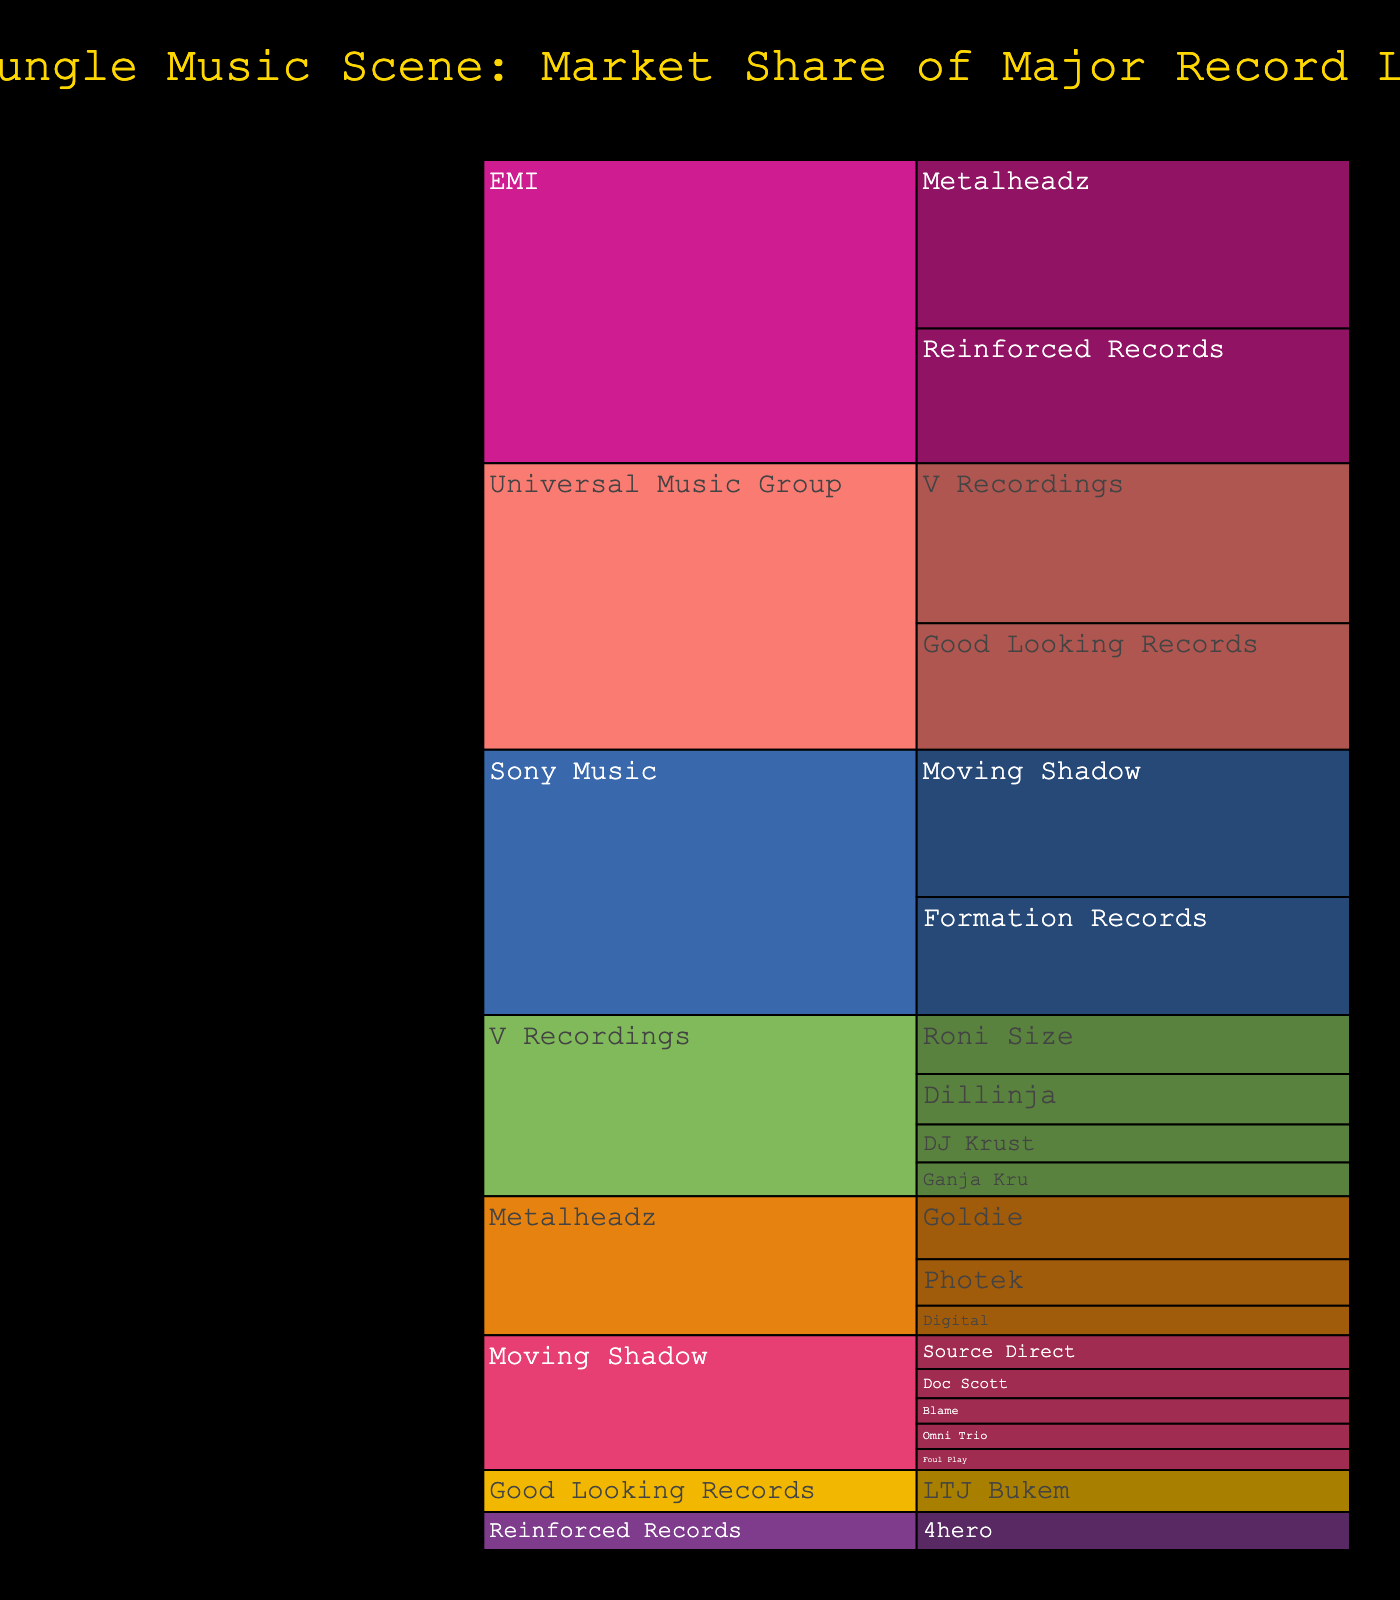What is the title of the chart? The title is written clearly at the top of the chart.
Answer: 90s Jungle Music Scene: Market Share of Major Record Labels Which label under EMI had the highest number of releases? By looking at the branches under EMI, you can see that Metalheadz had the highest number of releases.
Answer: Metalheadz How many releases did V Recordings have? Examine the segment for V Recordings directly on the chart.
Answer: 38 What is the combined number of releases for Sony Music’s labels? Add up the releases under all the labels associated with Sony Music (Moving Shadow, Formation Records). Using the chart: 35 (Moving Shadow) + 28 (Formation Records) = 63.
Answer: 63 Which artist under Metalheadz had the most releases? The chart branches further down from Metalheadz, and you can compare the values to find Goldie had the most.
Answer: Goldie How do the releases of Moving Shadow compare with Good Looking Records? Compare the values associated with Moving Shadow and Good Looking Records directly on the chart.
Answer: Moving Shadow has more releases (35 vs. 30) Who are the artists under V Recordings and what are their release counts? Identify the artists branching from V Recordings and check their values: Dillinja (12), Roni Size (14), Ganja Kru (8), and DJ Krust (9).
Answer: Dillinja (12), Roni Size (14), Ganja Kru (8), DJ Krust (9) Which parent label has the least number of total releases? Examine the sum of releases under each parent label and compare them: 
   Sony Music: 35 + 28 = 63
   EMI: 32 + 40 = 72
   Universal Music Group: 38 + 30 = 68
Sony Music has the smallest sum.
Answer: Sony Music What is the sum of releases for artists under Metalheadz? Add up the releases for all artists under Metalheadz: Goldie (15), Photek (11), Digital (7). Total: 15 + 11 + 7 = 33.
Answer: 33 